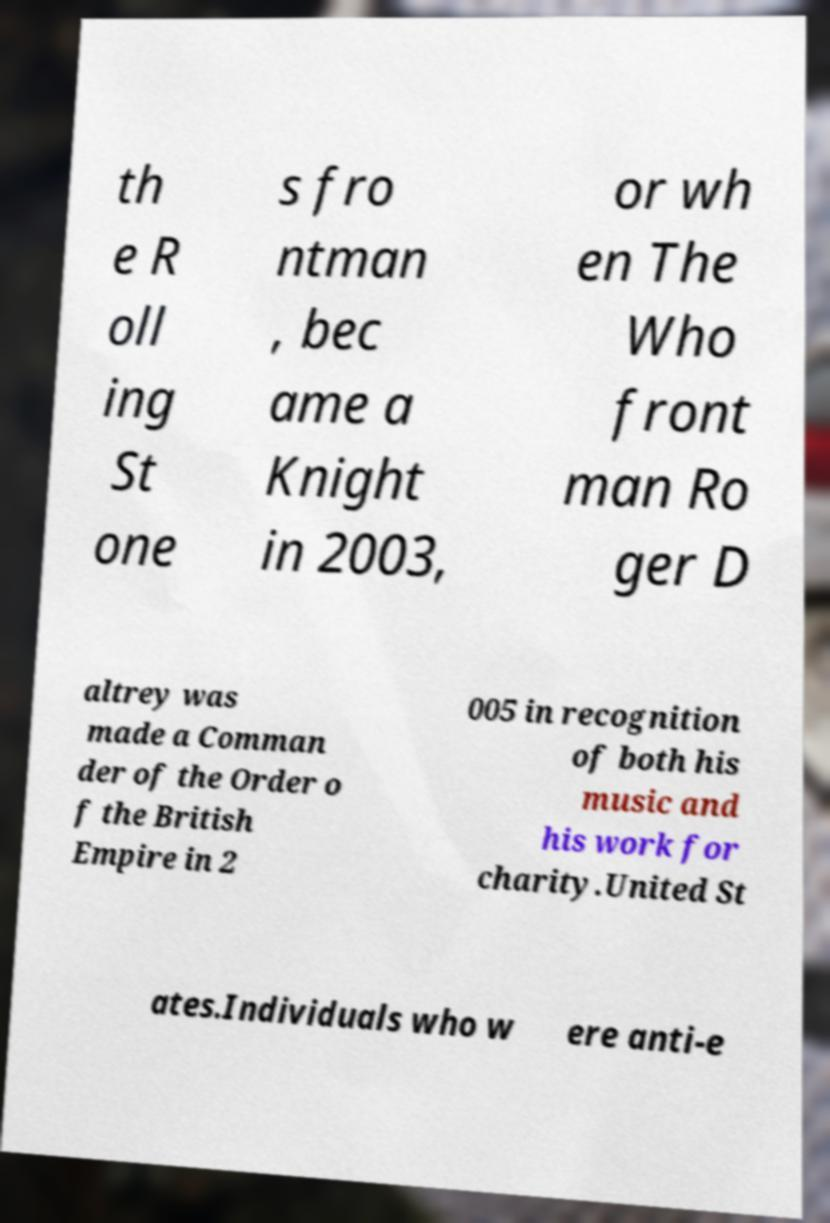I need the written content from this picture converted into text. Can you do that? th e R oll ing St one s fro ntman , bec ame a Knight in 2003, or wh en The Who front man Ro ger D altrey was made a Comman der of the Order o f the British Empire in 2 005 in recognition of both his music and his work for charity.United St ates.Individuals who w ere anti-e 